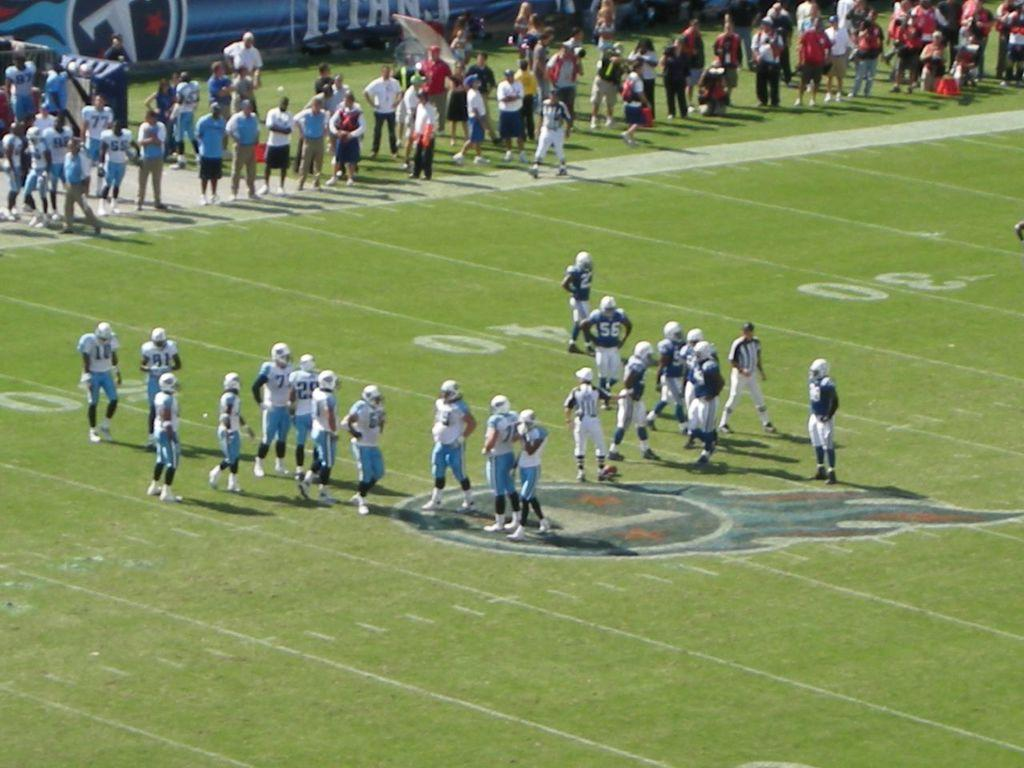What is happening in the image? There are people on the ground in the image. Can you describe the background of the image? There are objects visible in the background of the image. What advice is the person in the image giving to the waves? There is no person giving advice to waves in the image, as there are no waves present. 